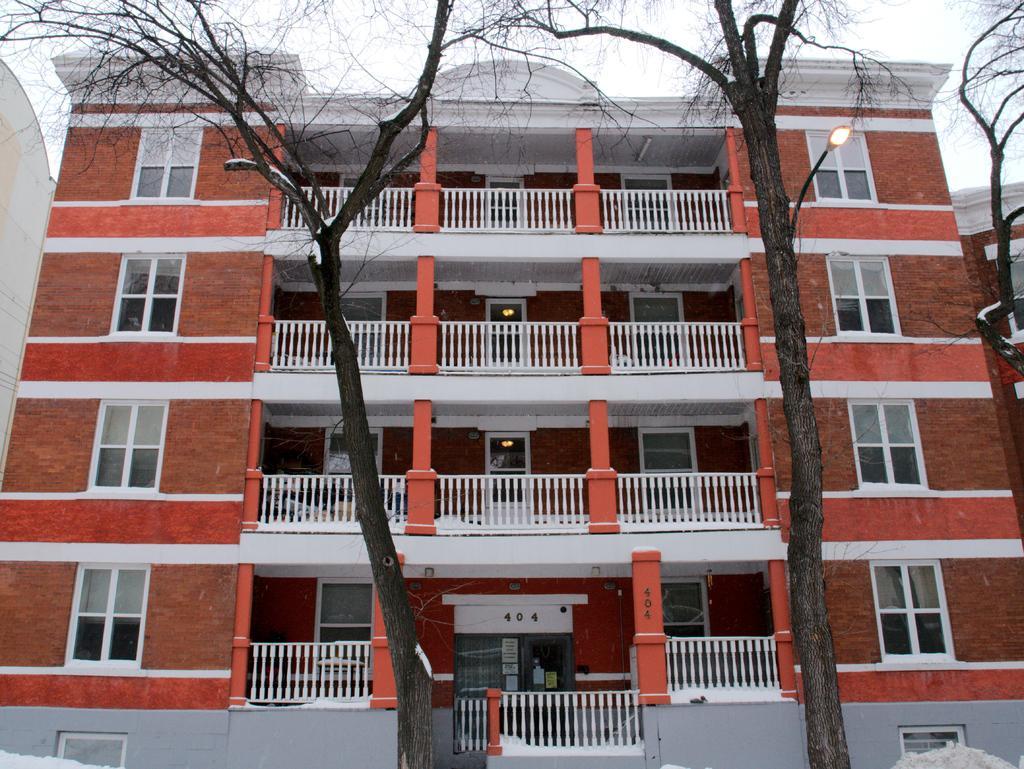Could you give a brief overview of what you see in this image? In this image we can see trees, street lights, building, windows, railings, doors, objects, wall and sky. 